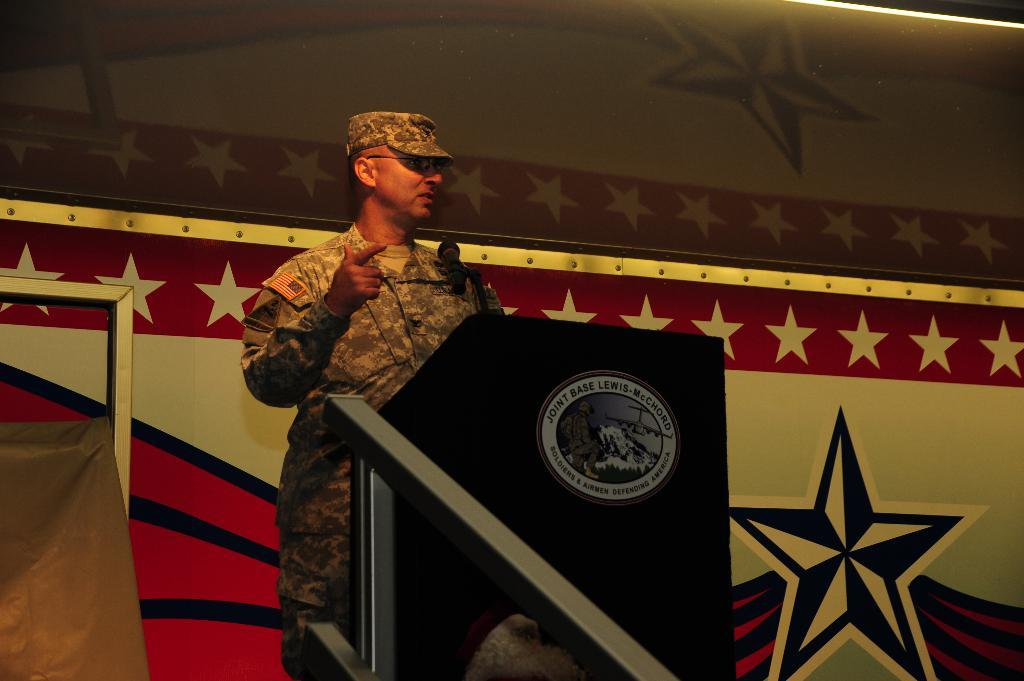What is the person in the image doing? The person is standing in the image. What type of clothing is the person wearing? The person is wearing a military uniform. What object is in front of the person? There is a podium in front of the person. What is on the podium? There is a microphone on the podium. What colors can be seen on the background wall? The background wall has red, white, and blue colors. What size is the drain visible in the image? There is no drain present in the image. 